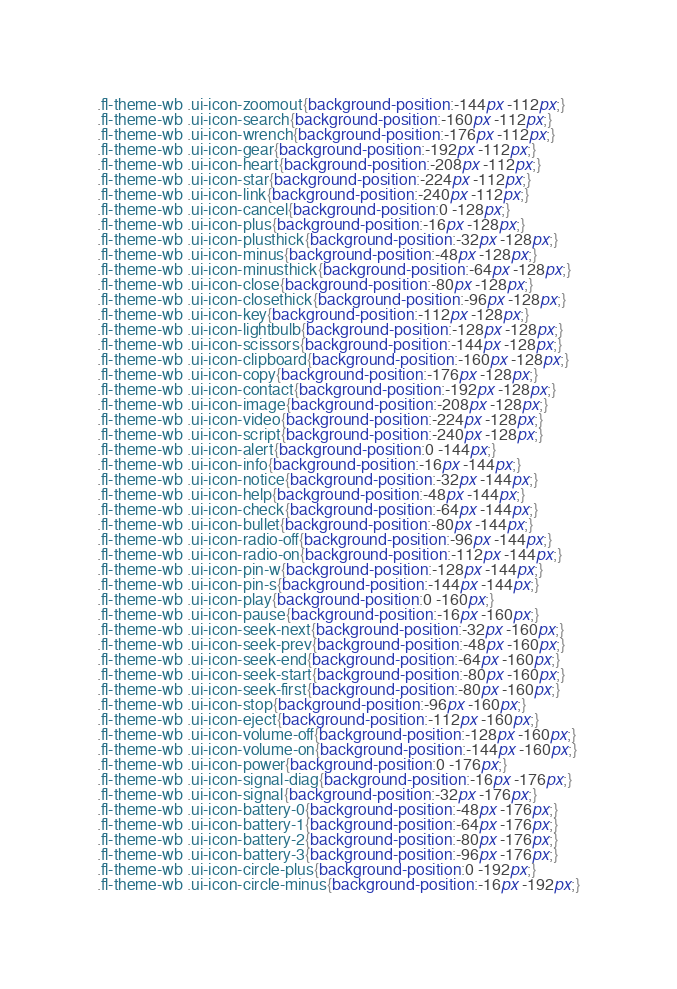Convert code to text. <code><loc_0><loc_0><loc_500><loc_500><_CSS_>.fl-theme-wb .ui-icon-zoomout{background-position:-144px -112px;}
.fl-theme-wb .ui-icon-search{background-position:-160px -112px;}
.fl-theme-wb .ui-icon-wrench{background-position:-176px -112px;}
.fl-theme-wb .ui-icon-gear{background-position:-192px -112px;}
.fl-theme-wb .ui-icon-heart{background-position:-208px -112px;}
.fl-theme-wb .ui-icon-star{background-position:-224px -112px;}
.fl-theme-wb .ui-icon-link{background-position:-240px -112px;}
.fl-theme-wb .ui-icon-cancel{background-position:0 -128px;}
.fl-theme-wb .ui-icon-plus{background-position:-16px -128px;}
.fl-theme-wb .ui-icon-plusthick{background-position:-32px -128px;}
.fl-theme-wb .ui-icon-minus{background-position:-48px -128px;}
.fl-theme-wb .ui-icon-minusthick{background-position:-64px -128px;}
.fl-theme-wb .ui-icon-close{background-position:-80px -128px;}
.fl-theme-wb .ui-icon-closethick{background-position:-96px -128px;}
.fl-theme-wb .ui-icon-key{background-position:-112px -128px;}
.fl-theme-wb .ui-icon-lightbulb{background-position:-128px -128px;}
.fl-theme-wb .ui-icon-scissors{background-position:-144px -128px;}
.fl-theme-wb .ui-icon-clipboard{background-position:-160px -128px;}
.fl-theme-wb .ui-icon-copy{background-position:-176px -128px;}
.fl-theme-wb .ui-icon-contact{background-position:-192px -128px;}
.fl-theme-wb .ui-icon-image{background-position:-208px -128px;}
.fl-theme-wb .ui-icon-video{background-position:-224px -128px;}
.fl-theme-wb .ui-icon-script{background-position:-240px -128px;}
.fl-theme-wb .ui-icon-alert{background-position:0 -144px;}
.fl-theme-wb .ui-icon-info{background-position:-16px -144px;}
.fl-theme-wb .ui-icon-notice{background-position:-32px -144px;}
.fl-theme-wb .ui-icon-help{background-position:-48px -144px;}
.fl-theme-wb .ui-icon-check{background-position:-64px -144px;}
.fl-theme-wb .ui-icon-bullet{background-position:-80px -144px;}
.fl-theme-wb .ui-icon-radio-off{background-position:-96px -144px;}
.fl-theme-wb .ui-icon-radio-on{background-position:-112px -144px;}
.fl-theme-wb .ui-icon-pin-w{background-position:-128px -144px;}
.fl-theme-wb .ui-icon-pin-s{background-position:-144px -144px;}
.fl-theme-wb .ui-icon-play{background-position:0 -160px;}
.fl-theme-wb .ui-icon-pause{background-position:-16px -160px;}
.fl-theme-wb .ui-icon-seek-next{background-position:-32px -160px;}
.fl-theme-wb .ui-icon-seek-prev{background-position:-48px -160px;}
.fl-theme-wb .ui-icon-seek-end{background-position:-64px -160px;}
.fl-theme-wb .ui-icon-seek-start{background-position:-80px -160px;}
.fl-theme-wb .ui-icon-seek-first{background-position:-80px -160px;}
.fl-theme-wb .ui-icon-stop{background-position:-96px -160px;}
.fl-theme-wb .ui-icon-eject{background-position:-112px -160px;}
.fl-theme-wb .ui-icon-volume-off{background-position:-128px -160px;}
.fl-theme-wb .ui-icon-volume-on{background-position:-144px -160px;}
.fl-theme-wb .ui-icon-power{background-position:0 -176px;}
.fl-theme-wb .ui-icon-signal-diag{background-position:-16px -176px;}
.fl-theme-wb .ui-icon-signal{background-position:-32px -176px;}
.fl-theme-wb .ui-icon-battery-0{background-position:-48px -176px;}
.fl-theme-wb .ui-icon-battery-1{background-position:-64px -176px;}
.fl-theme-wb .ui-icon-battery-2{background-position:-80px -176px;}
.fl-theme-wb .ui-icon-battery-3{background-position:-96px -176px;}
.fl-theme-wb .ui-icon-circle-plus{background-position:0 -192px;}
.fl-theme-wb .ui-icon-circle-minus{background-position:-16px -192px;}</code> 